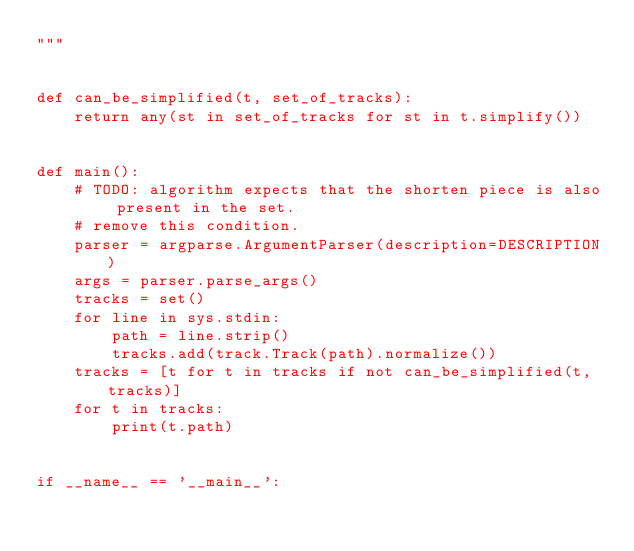Convert code to text. <code><loc_0><loc_0><loc_500><loc_500><_Python_>"""


def can_be_simplified(t, set_of_tracks):
    return any(st in set_of_tracks for st in t.simplify())


def main():
    # TODO: algorithm expects that the shorten piece is also present in the set.
    # remove this condition.
    parser = argparse.ArgumentParser(description=DESCRIPTION)
    args = parser.parse_args()
    tracks = set()
    for line in sys.stdin:
        path = line.strip()
        tracks.add(track.Track(path).normalize())
    tracks = [t for t in tracks if not can_be_simplified(t, tracks)]
    for t in tracks:
        print(t.path)


if __name__ == '__main__':</code> 